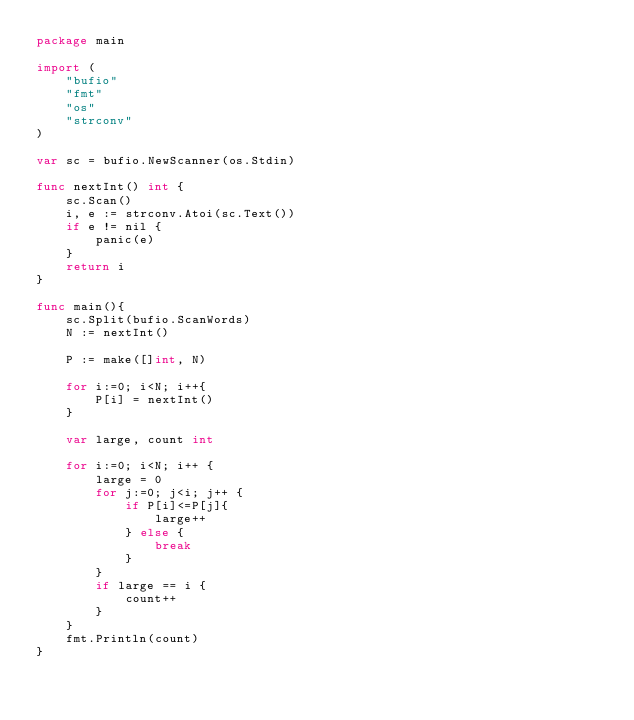Convert code to text. <code><loc_0><loc_0><loc_500><loc_500><_Go_>package main

import (
    "bufio"
    "fmt"
    "os"
    "strconv"
)

var sc = bufio.NewScanner(os.Stdin)

func nextInt() int {
    sc.Scan()
    i, e := strconv.Atoi(sc.Text())
    if e != nil {
        panic(e)
    }
    return i
}

func main(){
    sc.Split(bufio.ScanWords)
    N := nextInt()

    P := make([]int, N)

    for i:=0; i<N; i++{
        P[i] = nextInt()
    }

    var large, count int

    for i:=0; i<N; i++ {
        large = 0
        for j:=0; j<i; j++ {
            if P[i]<=P[j]{
                large++
            } else {
                break
            }
        }
        if large == i {
            count++
        }
    }
    fmt.Println(count)
}
</code> 